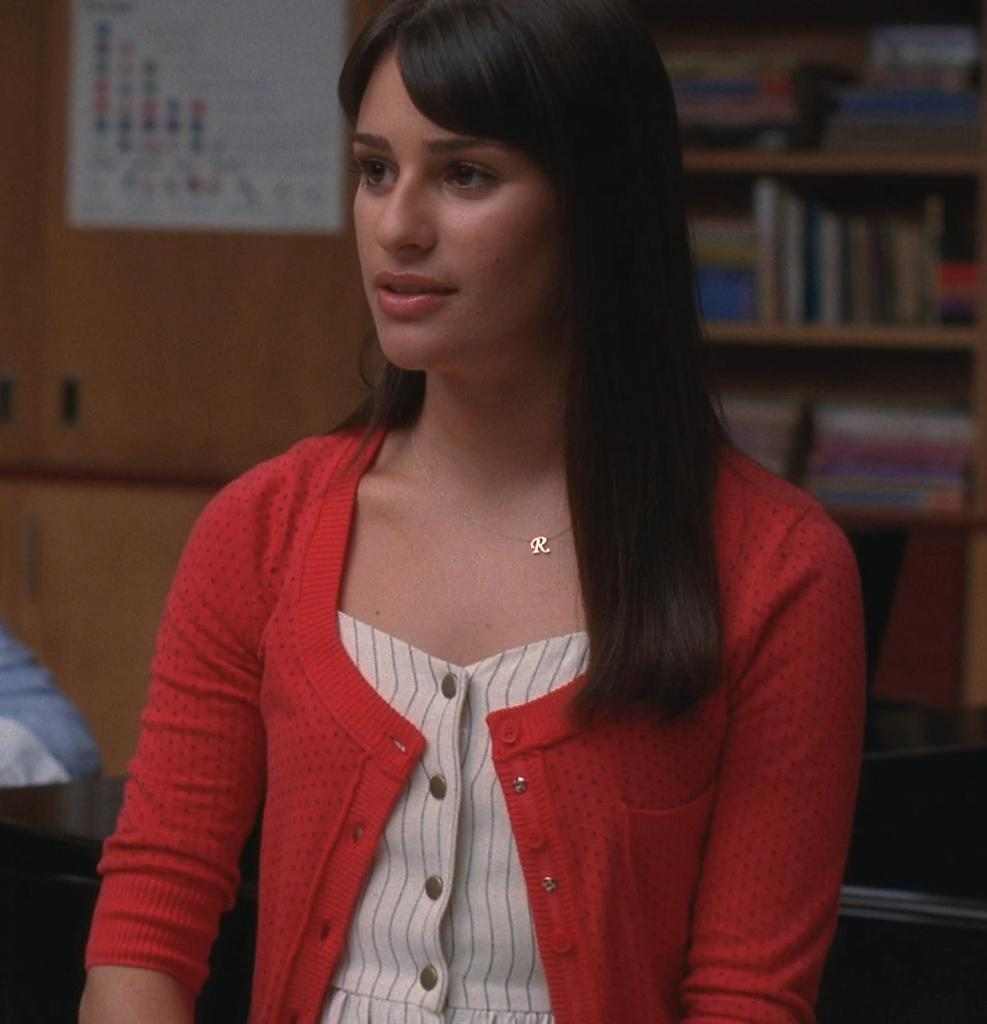Who is present in the image? There is a woman in the image. What can be seen in the background of the image? There are books arranged in shelves and a paper pasted on a cupboard in the background of the image. How many pizzas are being pulled out of the oven in the image? There are no pizzas or ovens present in the image. What type of songs can be heard playing in the background of the image? There is no audio or music present in the image. 